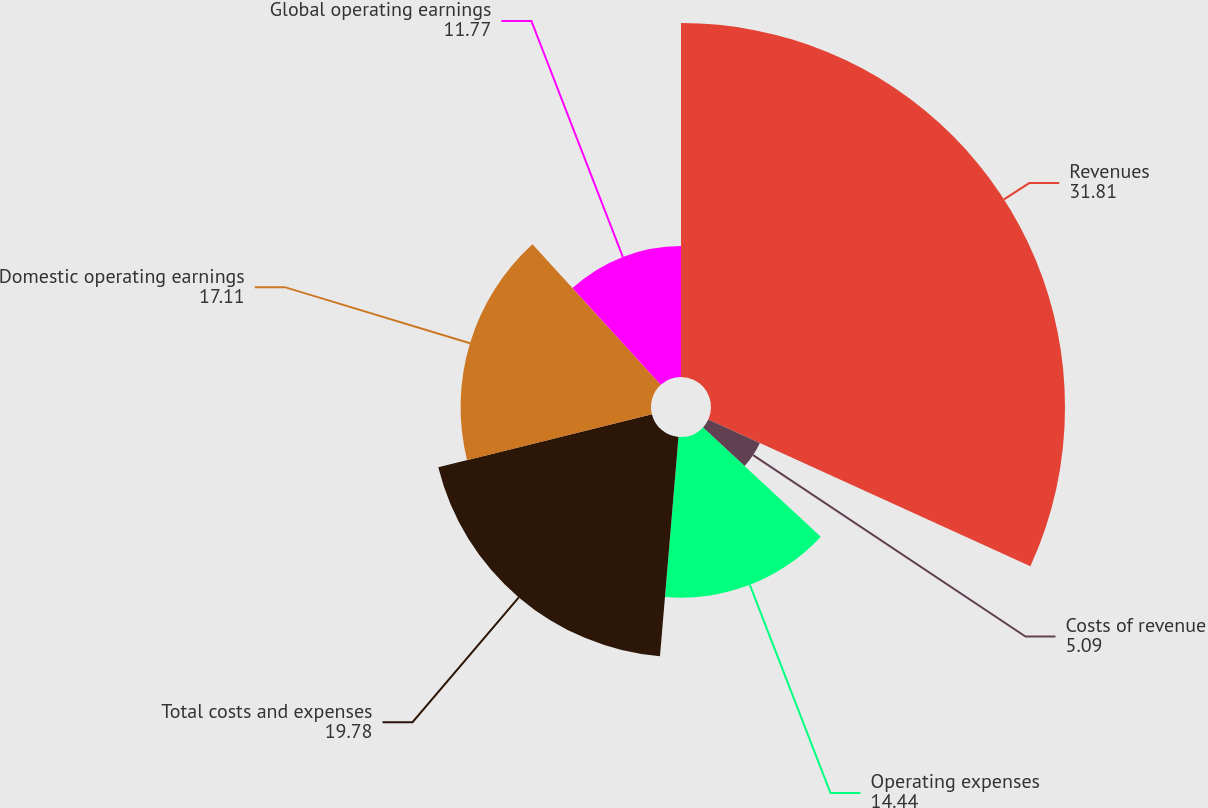Convert chart. <chart><loc_0><loc_0><loc_500><loc_500><pie_chart><fcel>Revenues<fcel>Costs of revenue<fcel>Operating expenses<fcel>Total costs and expenses<fcel>Domestic operating earnings<fcel>Global operating earnings<nl><fcel>31.81%<fcel>5.09%<fcel>14.44%<fcel>19.78%<fcel>17.11%<fcel>11.77%<nl></chart> 